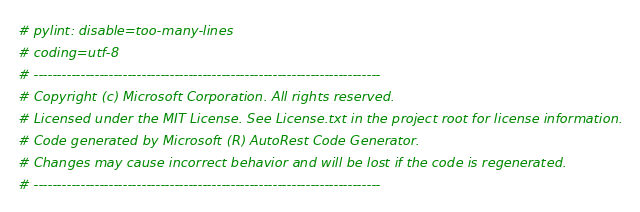<code> <loc_0><loc_0><loc_500><loc_500><_Python_># pylint: disable=too-many-lines
# coding=utf-8
# --------------------------------------------------------------------------
# Copyright (c) Microsoft Corporation. All rights reserved.
# Licensed under the MIT License. See License.txt in the project root for license information.
# Code generated by Microsoft (R) AutoRest Code Generator.
# Changes may cause incorrect behavior and will be lost if the code is regenerated.
# --------------------------------------------------------------------------</code> 